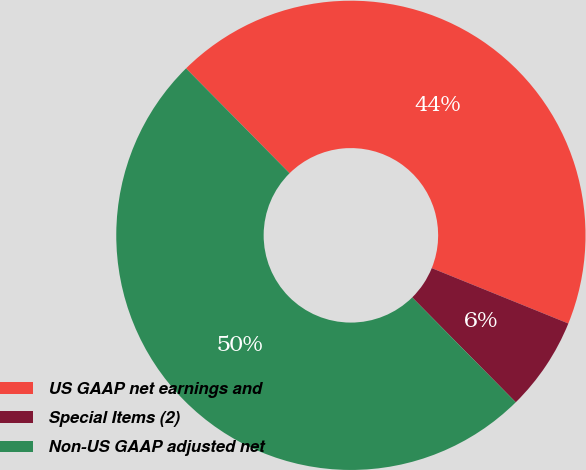Convert chart. <chart><loc_0><loc_0><loc_500><loc_500><pie_chart><fcel>US GAAP net earnings and<fcel>Special Items (2)<fcel>Non-US GAAP adjusted net<nl><fcel>43.53%<fcel>6.47%<fcel>50.0%<nl></chart> 